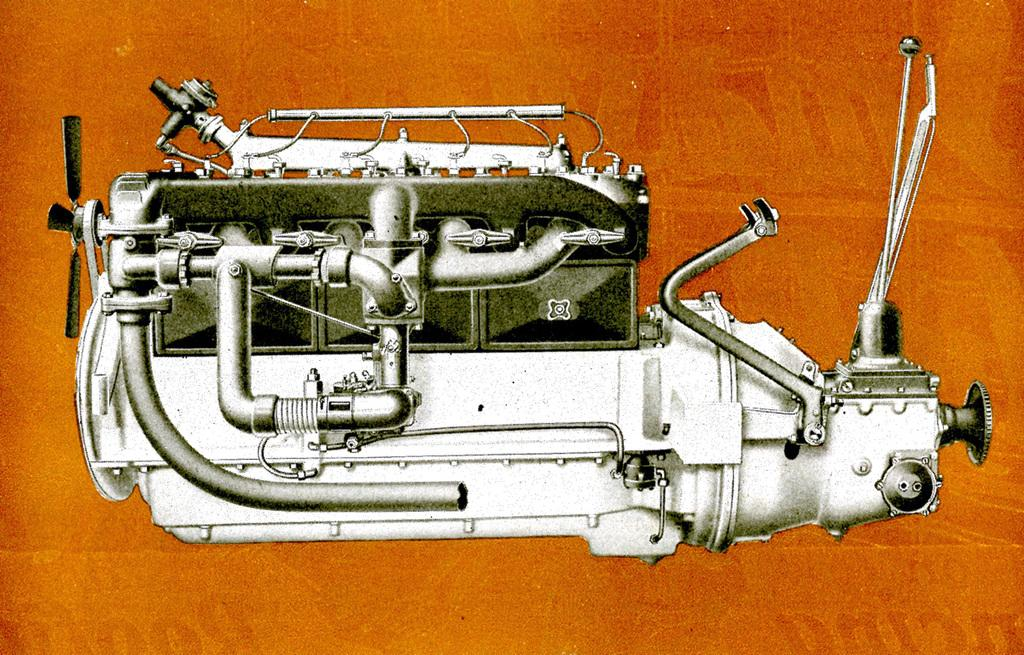What is the main subject of the picture? The main subject of the picture is an engine. Can you describe the color of the engine? The engine is silver in color. What can be seen in the background of the image? The background of the image is orange. Can you tell me how much paste is being used to fix the engine in the image? There is no paste or any indication of repair work being done in the image; it simply shows an engine with an orange background. 